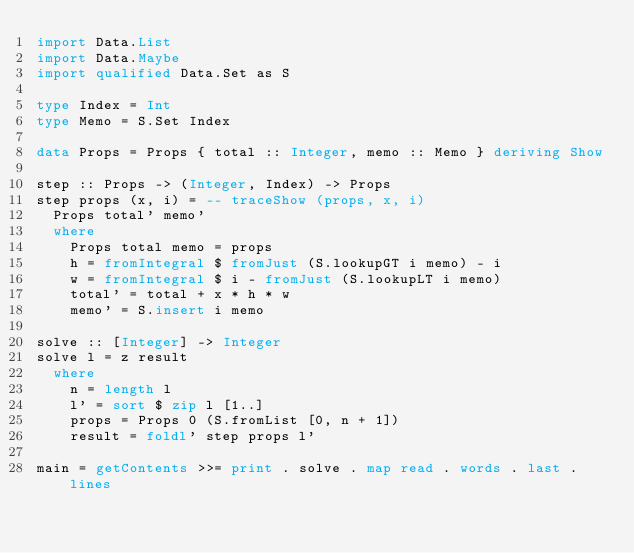<code> <loc_0><loc_0><loc_500><loc_500><_Haskell_>import Data.List
import Data.Maybe
import qualified Data.Set as S

type Index = Int
type Memo = S.Set Index

data Props = Props { total :: Integer, memo :: Memo } deriving Show

step :: Props -> (Integer, Index) -> Props
step props (x, i) = -- traceShow (props, x, i)
  Props total' memo'
  where
    Props total memo = props
    h = fromIntegral $ fromJust (S.lookupGT i memo) - i
    w = fromIntegral $ i - fromJust (S.lookupLT i memo)
    total' = total + x * h * w
    memo' = S.insert i memo

solve :: [Integer] -> Integer
solve l = z result
  where
    n = length l
    l' = sort $ zip l [1..]
    props = Props 0 (S.fromList [0, n + 1])
    result = foldl' step props l'

main = getContents >>= print . solve . map read . words . last . lines
</code> 